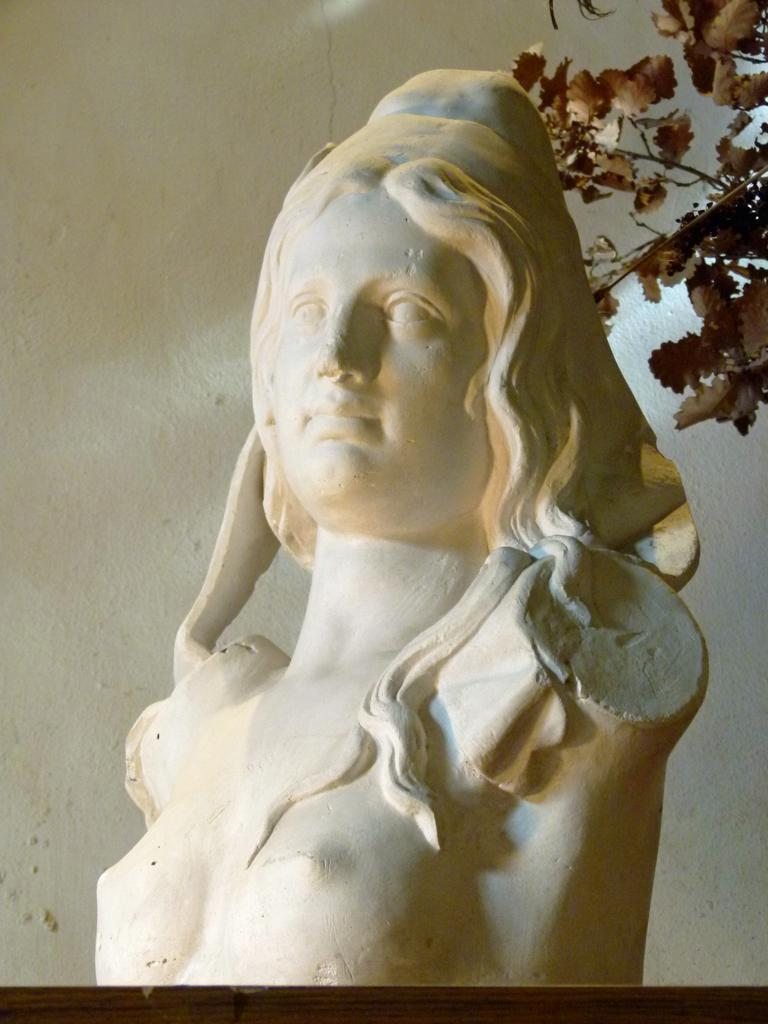What is placed on the table in the image? There is an idol on the table. What can be seen on the right side of the image? There are branches with leaves on the right side of the image. What is visible in the background of the image? There is a wall in the background of the image. Where is the plantation located in the image? There is no plantation present in the image. Can you see a boy playing in the image? There is no boy present in the image. 